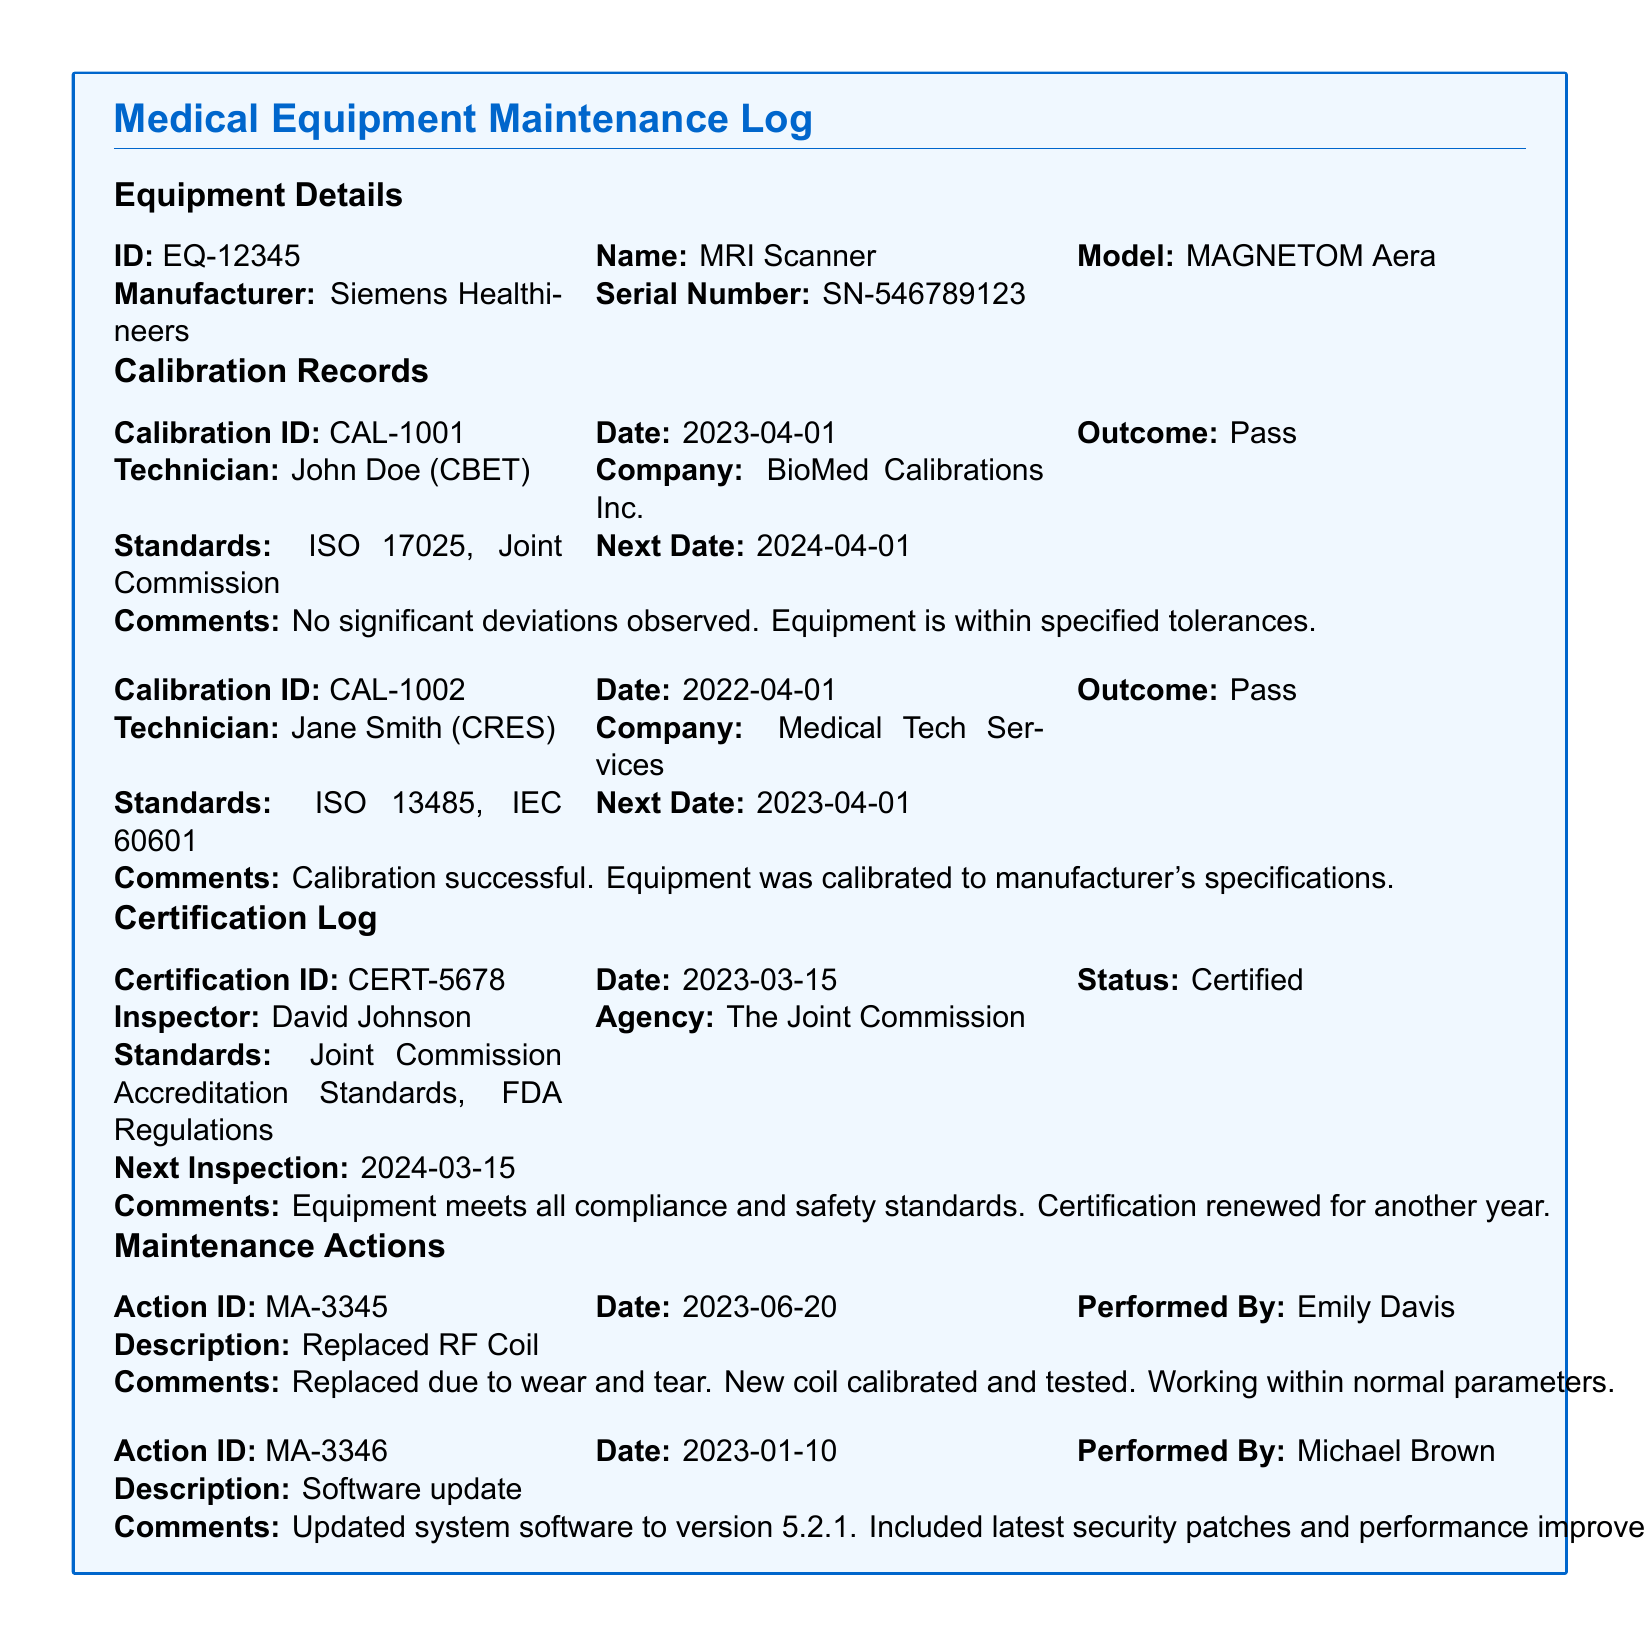What is the ID of the equipment? The ID of the equipment is mentioned in the Equipment Details section of the document.
Answer: EQ-12345 Who performed the calibration on 2023-04-01? The technician who performed the calibration on this date is noted in the Calibration Records section.
Answer: John Doe What is the outcome of Calibration ID CAL-1002? The outcome of the calibration is specified in the Calibration Records for that ID.
Answer: Pass When is the next inspection due according to the Certification Log? The next inspection date is listed in the Certification Log section.
Answer: 2024-03-15 What maintenance action was performed on 2023-06-20? The description of the maintenance action is recorded in the Maintenance Actions section.
Answer: Replaced RF Coil What standard does the latest calibration comply with? The standards followed during the calibration are mentioned in the Calibration Records.
Answer: ISO 17025, Joint Commission Who inspected the equipment for certification? The inspector's name is provided in the Certification Log section.
Answer: David Johnson What is the purpose of the maintenance actions listed? The maintenance actions describe what was performed on the equipment and their nature.
Answer: Maintenance What is the serial number of the MRI scanner? The serial number is detailed in the Equipment Details section of the document.
Answer: SN-546789123 What date was the last software update carried out? The date of the last software update is recorded in the Maintenance Actions section.
Answer: 2023-01-10 